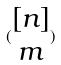Convert formula to latex. <formula><loc_0><loc_0><loc_500><loc_500>( \begin{matrix} [ n ] \\ m \end{matrix} )</formula> 